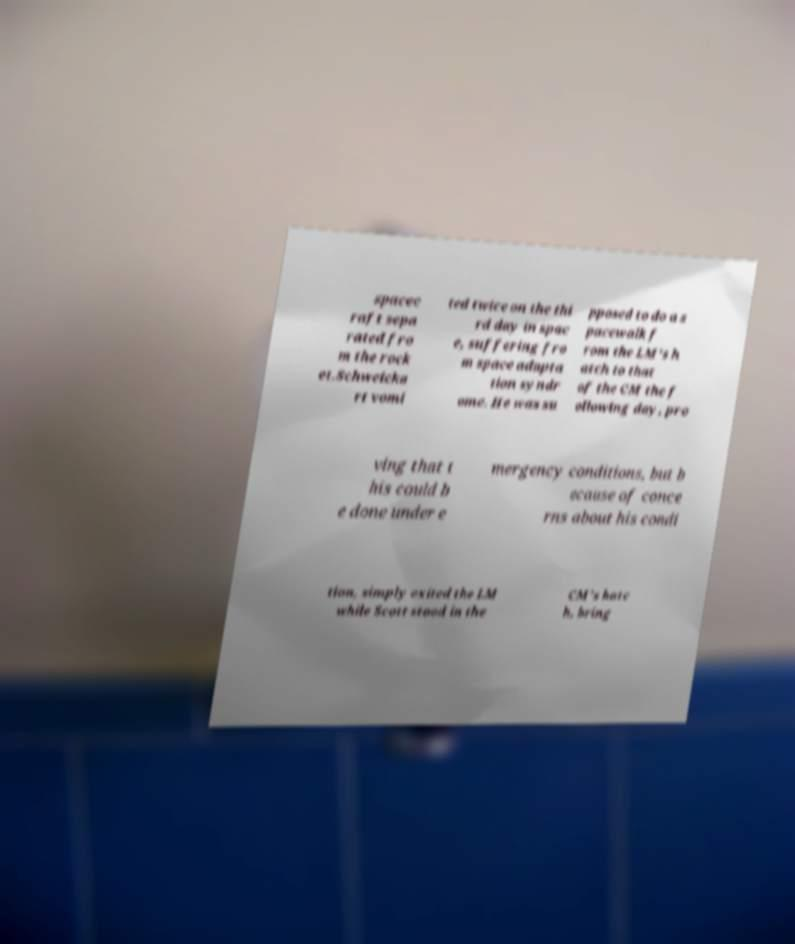There's text embedded in this image that I need extracted. Can you transcribe it verbatim? spacec raft sepa rated fro m the rock et.Schweicka rt vomi ted twice on the thi rd day in spac e, suffering fro m space adapta tion syndr ome. He was su pposed to do a s pacewalk f rom the LM's h atch to that of the CM the f ollowing day, pro ving that t his could b e done under e mergency conditions, but b ecause of conce rns about his condi tion, simply exited the LM while Scott stood in the CM's hatc h, bring 